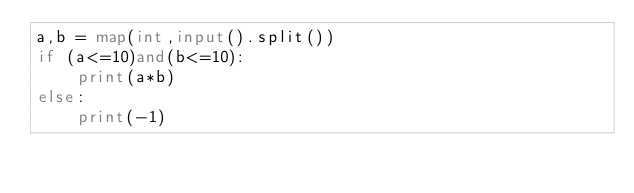Convert code to text. <code><loc_0><loc_0><loc_500><loc_500><_Python_>a,b = map(int,input().split())
if (a<=10)and(b<=10):
    print(a*b)
else: 
    print(-1)</code> 